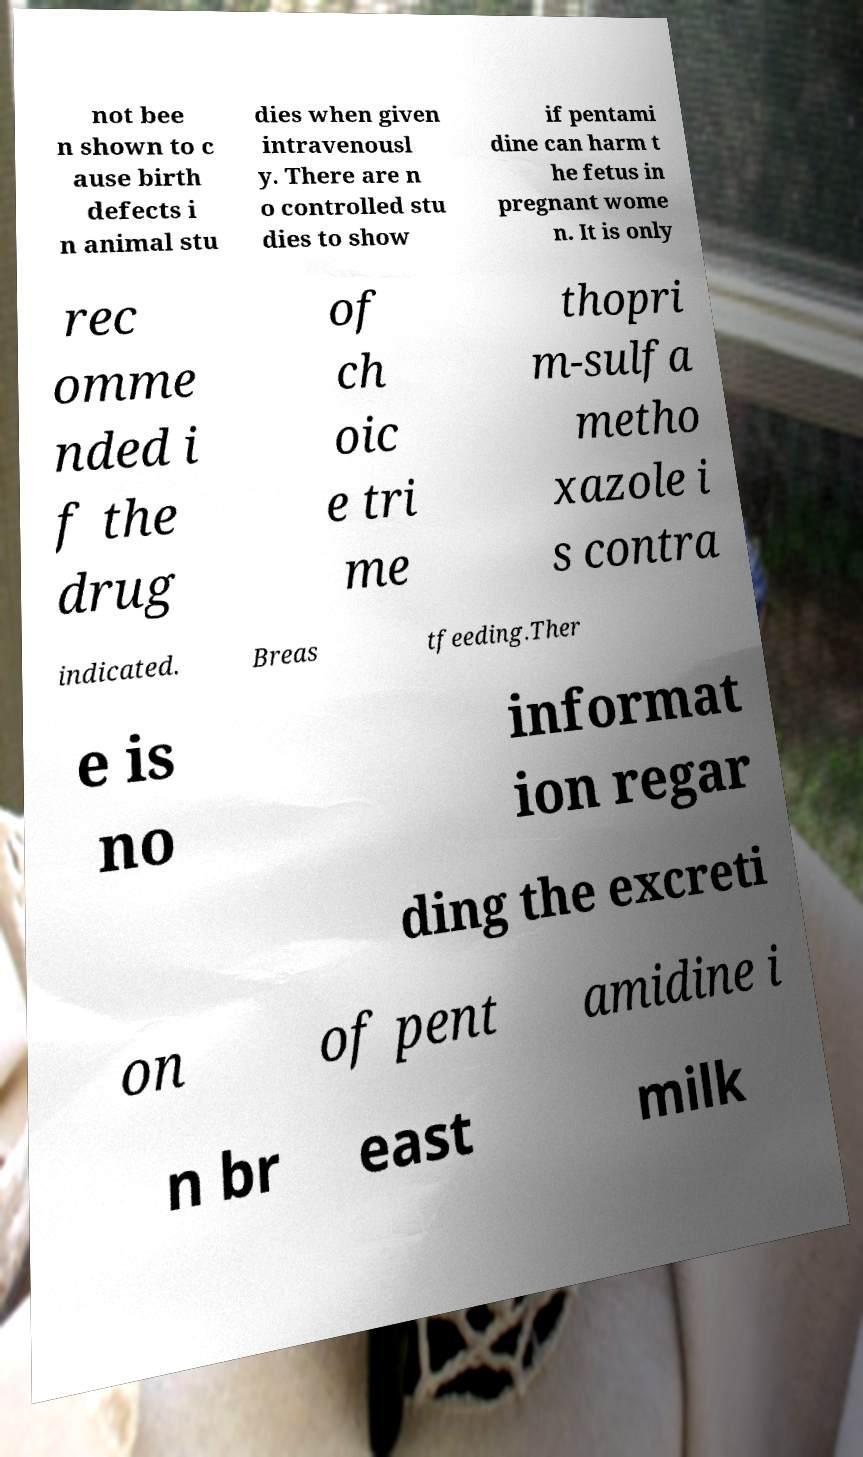For documentation purposes, I need the text within this image transcribed. Could you provide that? not bee n shown to c ause birth defects i n animal stu dies when given intravenousl y. There are n o controlled stu dies to show if pentami dine can harm t he fetus in pregnant wome n. It is only rec omme nded i f the drug of ch oic e tri me thopri m-sulfa metho xazole i s contra indicated. Breas tfeeding.Ther e is no informat ion regar ding the excreti on of pent amidine i n br east milk 